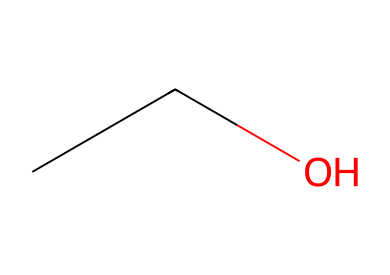How many carbon atoms are present in this molecule? The SMILES representation "CCO" indicates there are two carbon atoms, as each "C" represents a carbon atom.
Answer: 2 What is the chemical name of this compound? The chemical represented by "CCO" is ethanol, which is a common alcohol used in hand sanitizers.
Answer: ethanol Is this chemical flammable? Ethanol is classified as a flammable liquid due to its structure, which includes a carbon chain and hydroxyl group that facilitates ignition.
Answer: yes What is the functional group present in this molecule? The "O" in the SMILES "CCO" indicates a hydroxyl (-OH) functional group, which is characteristic of alcohols such as ethanol.
Answer: hydroxyl How many hydrogen atoms are in this molecule? Counting the hydrogen atoms, the two carbons (C) each can bond with up to three hydrogens, and the oxygen (O) can participate in the bonding, leading to a total of six hydrogens in ethanol.
Answer: 6 What is the state of ethanol at room temperature? Ethanol is a liquid at room temperature, which can be inferred from its structure as a simple alcohol with low molecular weight and volatility.
Answer: liquid Why is ethanol effective as a hand sanitizer? The presence of the hydroxyl functional group and its ability to disrupt bacterial cell membranes make ethanol effective as an antiseptic; the chemical structure supports these properties.
Answer: disrupts cell membranes 